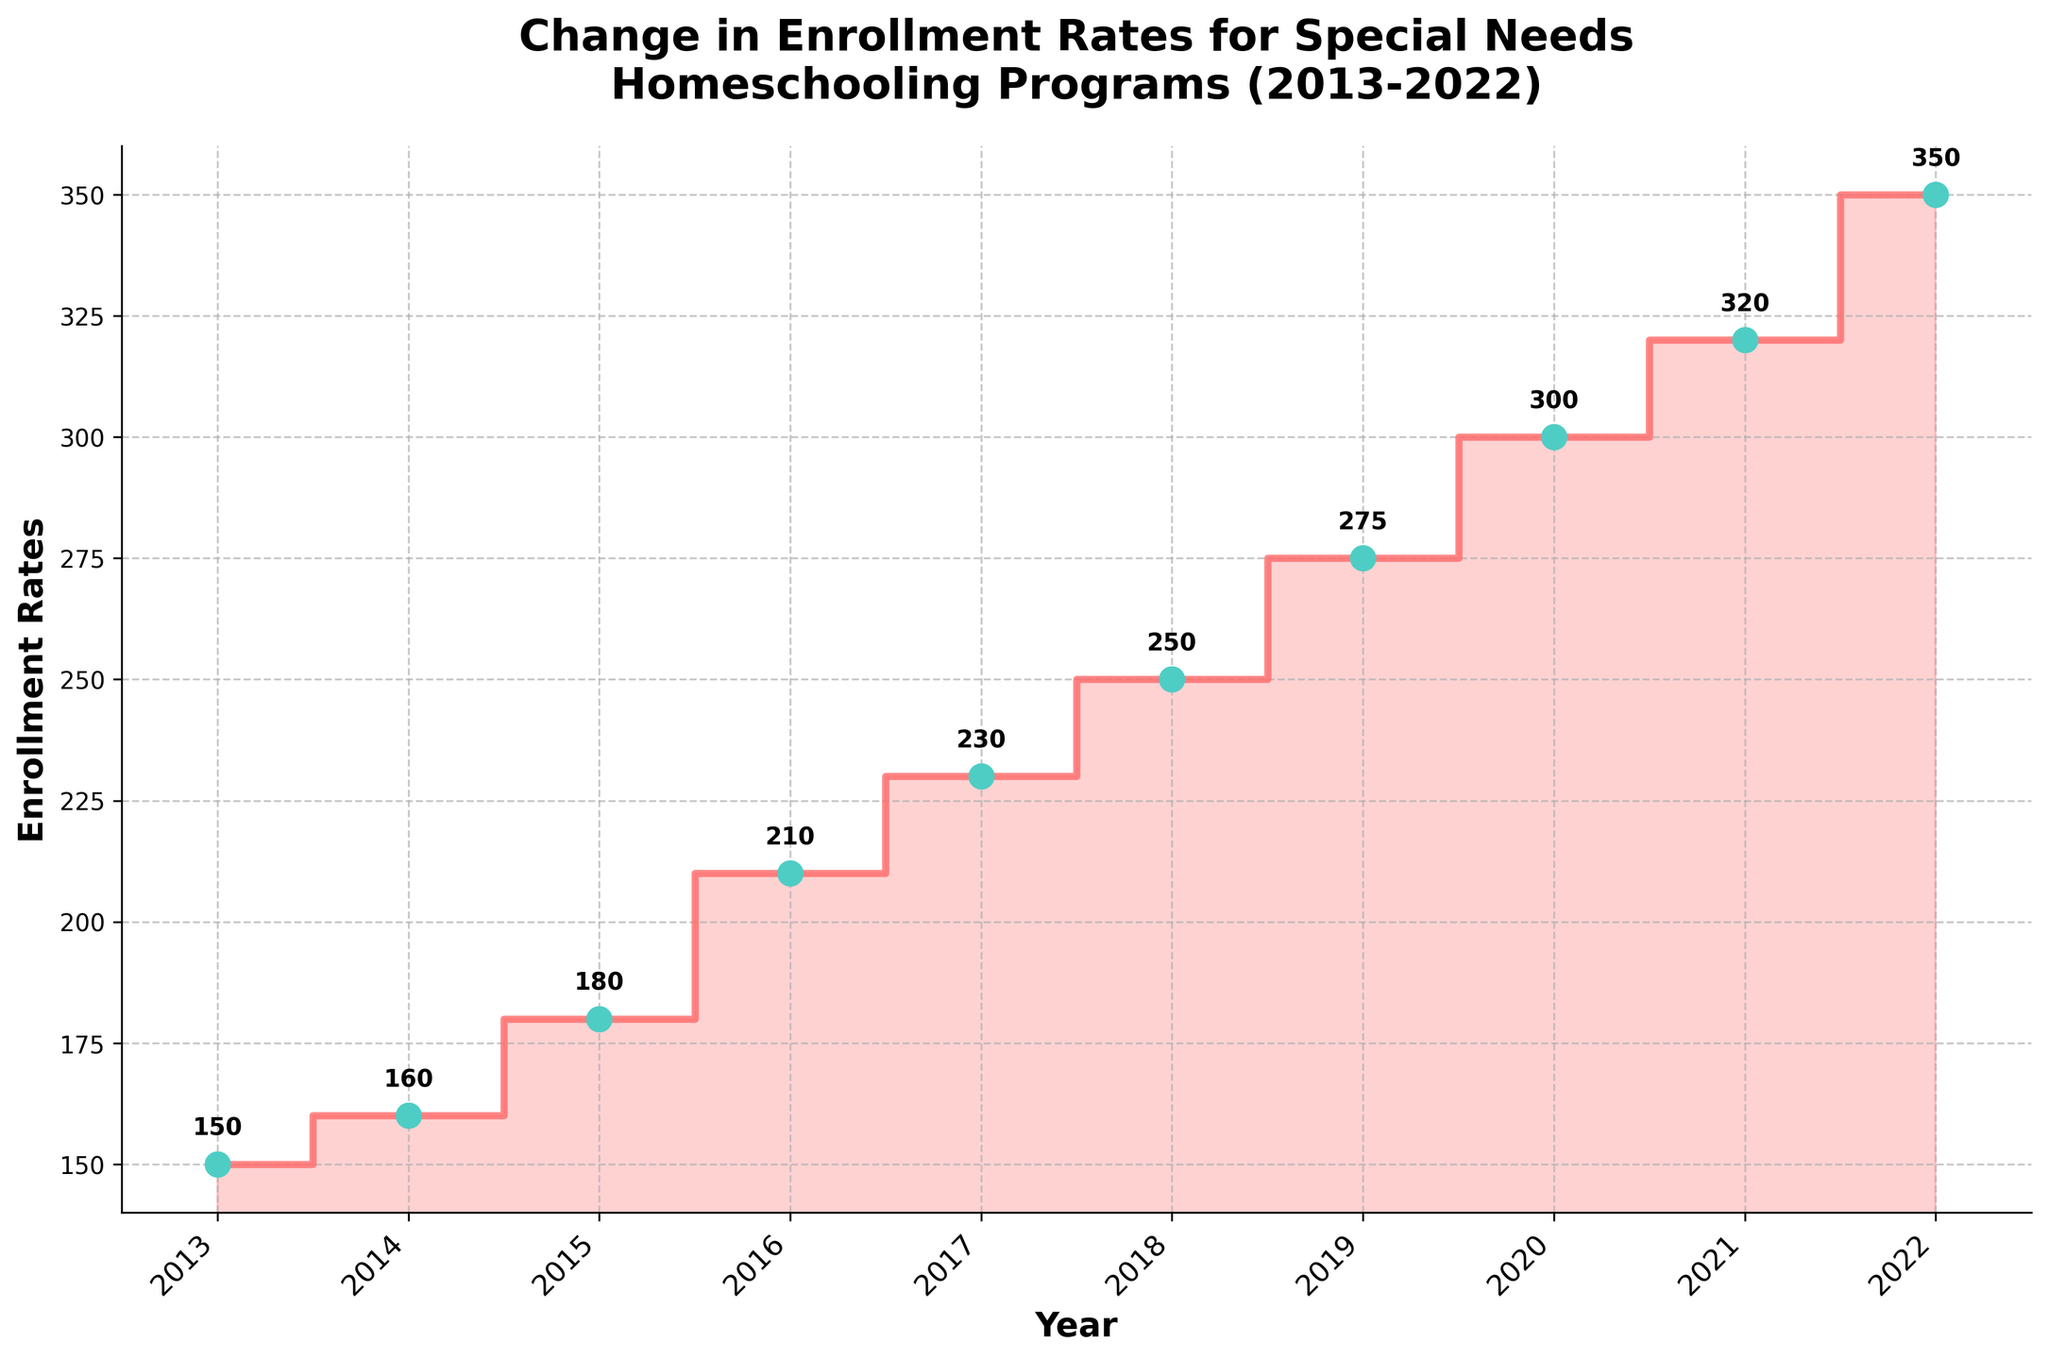How many years are represented in the plot? There are data points displayed from the year 2013 to 2022. Counting each year gives us 10 years.
Answer: 10 What does the y-axis represent? The figure's y-axis is labeled 'Enrollment Rates,' indicating it represents the enrollment rates for special needs homeschooling programs.
Answer: Enrollment Rates In which year did the enrollment rates first reach 300? Looking at the plot, the line intersects the 300-mark in the year 2020.
Answer: 2020 What is the overall trend in the enrollment rates over the past decade? The step plot shows that the enrollment rates have been increasing steadily from 2013 to 2022.
Answer: Increasing How much did the enrollment rates increase between 2013 and 2022? The enrollment rates in 2013 were 150, and in 2022 they were 350. The difference is 350 - 150 = 200.
Answer: 200 Which year had the highest enrollment rate? From the plot, the highest enrollment rate is at the year 2022, with a rate of 350.
Answer: 2022 Between which two consecutive years was the largest increase in enrollment rates observed? Observing the differences between the consecutive years: 2013-2014 (10), 2014-2015 (20), 2015-2016 (30), 2016-2017 (20), 2017-2018 (20), 2018-2019 (25), 2019-2020 (25), 2020-2021 (20), 2021-2022 (30). The largest increase is between 2015 and 2016 and between 2021 and 2022, both with an increase of 30.
Answer: 2015-2016 and 2021-2022 What's the average enrollment rate over the decade? The enrollment rates are [150, 160, 180, 210, 230, 250, 275, 300, 320, 350]. Summing these rates gives 2425. Dividing by the number of years (10) gives an average of 2425 / 10 = 242.5.
Answer: 242.5 What was the enrollment rate in 2017 and how much did it change compared to 2018? The enrollment rate in 2017 was 230. In 2018, it was 250. The change is 250 - 230 = 20.
Answer: 20 What does the filled area below the step line represent? The filled area below the step line visually represents the overall volume of enrollment rates over the displayed years, highlighting the accumulation and rise over time.
Answer: Cumulative Enrollment Rates 